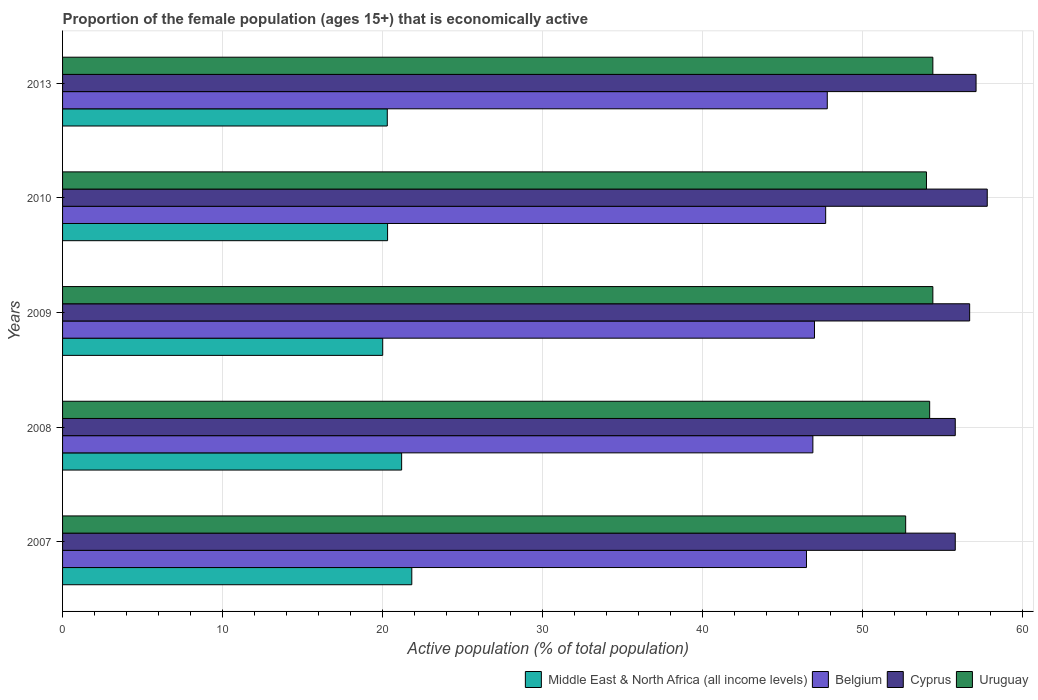Are the number of bars on each tick of the Y-axis equal?
Offer a very short reply. Yes. How many bars are there on the 5th tick from the bottom?
Your response must be concise. 4. What is the proportion of the female population that is economically active in Cyprus in 2007?
Give a very brief answer. 55.8. Across all years, what is the maximum proportion of the female population that is economically active in Uruguay?
Ensure brevity in your answer.  54.4. Across all years, what is the minimum proportion of the female population that is economically active in Cyprus?
Your response must be concise. 55.8. What is the total proportion of the female population that is economically active in Uruguay in the graph?
Your answer should be very brief. 269.7. What is the difference between the proportion of the female population that is economically active in Belgium in 2008 and that in 2009?
Provide a succinct answer. -0.1. What is the difference between the proportion of the female population that is economically active in Uruguay in 2009 and the proportion of the female population that is economically active in Cyprus in 2013?
Ensure brevity in your answer.  -2.7. What is the average proportion of the female population that is economically active in Cyprus per year?
Your response must be concise. 56.64. In the year 2013, what is the difference between the proportion of the female population that is economically active in Uruguay and proportion of the female population that is economically active in Cyprus?
Offer a very short reply. -2.7. In how many years, is the proportion of the female population that is economically active in Uruguay greater than 32 %?
Offer a very short reply. 5. What is the ratio of the proportion of the female population that is economically active in Belgium in 2007 to that in 2008?
Provide a short and direct response. 0.99. What is the difference between the highest and the second highest proportion of the female population that is economically active in Cyprus?
Your response must be concise. 0.7. What is the difference between the highest and the lowest proportion of the female population that is economically active in Middle East & North Africa (all income levels)?
Keep it short and to the point. 1.82. Is it the case that in every year, the sum of the proportion of the female population that is economically active in Middle East & North Africa (all income levels) and proportion of the female population that is economically active in Belgium is greater than the sum of proportion of the female population that is economically active in Uruguay and proportion of the female population that is economically active in Cyprus?
Your response must be concise. No. What does the 1st bar from the top in 2007 represents?
Your answer should be compact. Uruguay. What does the 4th bar from the bottom in 2010 represents?
Give a very brief answer. Uruguay. Is it the case that in every year, the sum of the proportion of the female population that is economically active in Middle East & North Africa (all income levels) and proportion of the female population that is economically active in Uruguay is greater than the proportion of the female population that is economically active in Belgium?
Keep it short and to the point. Yes. How many bars are there?
Provide a short and direct response. 20. How many years are there in the graph?
Offer a very short reply. 5. Are the values on the major ticks of X-axis written in scientific E-notation?
Ensure brevity in your answer.  No. How are the legend labels stacked?
Provide a short and direct response. Horizontal. What is the title of the graph?
Make the answer very short. Proportion of the female population (ages 15+) that is economically active. What is the label or title of the X-axis?
Your answer should be very brief. Active population (% of total population). What is the label or title of the Y-axis?
Provide a short and direct response. Years. What is the Active population (% of total population) of Middle East & North Africa (all income levels) in 2007?
Provide a succinct answer. 21.83. What is the Active population (% of total population) in Belgium in 2007?
Your response must be concise. 46.5. What is the Active population (% of total population) of Cyprus in 2007?
Keep it short and to the point. 55.8. What is the Active population (% of total population) in Uruguay in 2007?
Give a very brief answer. 52.7. What is the Active population (% of total population) of Middle East & North Africa (all income levels) in 2008?
Offer a very short reply. 21.19. What is the Active population (% of total population) in Belgium in 2008?
Offer a very short reply. 46.9. What is the Active population (% of total population) in Cyprus in 2008?
Provide a succinct answer. 55.8. What is the Active population (% of total population) in Uruguay in 2008?
Your answer should be compact. 54.2. What is the Active population (% of total population) of Middle East & North Africa (all income levels) in 2009?
Offer a terse response. 20.01. What is the Active population (% of total population) in Cyprus in 2009?
Give a very brief answer. 56.7. What is the Active population (% of total population) of Uruguay in 2009?
Give a very brief answer. 54.4. What is the Active population (% of total population) of Middle East & North Africa (all income levels) in 2010?
Your answer should be very brief. 20.32. What is the Active population (% of total population) in Belgium in 2010?
Offer a very short reply. 47.7. What is the Active population (% of total population) of Cyprus in 2010?
Offer a very short reply. 57.8. What is the Active population (% of total population) of Uruguay in 2010?
Your answer should be very brief. 54. What is the Active population (% of total population) of Middle East & North Africa (all income levels) in 2013?
Give a very brief answer. 20.3. What is the Active population (% of total population) in Belgium in 2013?
Offer a terse response. 47.8. What is the Active population (% of total population) in Cyprus in 2013?
Your response must be concise. 57.1. What is the Active population (% of total population) in Uruguay in 2013?
Your answer should be very brief. 54.4. Across all years, what is the maximum Active population (% of total population) of Middle East & North Africa (all income levels)?
Keep it short and to the point. 21.83. Across all years, what is the maximum Active population (% of total population) in Belgium?
Keep it short and to the point. 47.8. Across all years, what is the maximum Active population (% of total population) of Cyprus?
Provide a succinct answer. 57.8. Across all years, what is the maximum Active population (% of total population) in Uruguay?
Offer a terse response. 54.4. Across all years, what is the minimum Active population (% of total population) of Middle East & North Africa (all income levels)?
Ensure brevity in your answer.  20.01. Across all years, what is the minimum Active population (% of total population) of Belgium?
Your answer should be compact. 46.5. Across all years, what is the minimum Active population (% of total population) in Cyprus?
Your answer should be compact. 55.8. Across all years, what is the minimum Active population (% of total population) in Uruguay?
Offer a very short reply. 52.7. What is the total Active population (% of total population) of Middle East & North Africa (all income levels) in the graph?
Offer a terse response. 103.65. What is the total Active population (% of total population) in Belgium in the graph?
Provide a short and direct response. 235.9. What is the total Active population (% of total population) of Cyprus in the graph?
Your response must be concise. 283.2. What is the total Active population (% of total population) in Uruguay in the graph?
Make the answer very short. 269.7. What is the difference between the Active population (% of total population) of Middle East & North Africa (all income levels) in 2007 and that in 2008?
Give a very brief answer. 0.63. What is the difference between the Active population (% of total population) of Belgium in 2007 and that in 2008?
Provide a succinct answer. -0.4. What is the difference between the Active population (% of total population) of Uruguay in 2007 and that in 2008?
Provide a short and direct response. -1.5. What is the difference between the Active population (% of total population) of Middle East & North Africa (all income levels) in 2007 and that in 2009?
Provide a short and direct response. 1.82. What is the difference between the Active population (% of total population) in Cyprus in 2007 and that in 2009?
Your answer should be compact. -0.9. What is the difference between the Active population (% of total population) in Uruguay in 2007 and that in 2009?
Offer a terse response. -1.7. What is the difference between the Active population (% of total population) in Middle East & North Africa (all income levels) in 2007 and that in 2010?
Give a very brief answer. 1.51. What is the difference between the Active population (% of total population) of Cyprus in 2007 and that in 2010?
Ensure brevity in your answer.  -2. What is the difference between the Active population (% of total population) in Middle East & North Africa (all income levels) in 2007 and that in 2013?
Provide a succinct answer. 1.53. What is the difference between the Active population (% of total population) of Belgium in 2007 and that in 2013?
Your answer should be very brief. -1.3. What is the difference between the Active population (% of total population) of Cyprus in 2007 and that in 2013?
Your answer should be compact. -1.3. What is the difference between the Active population (% of total population) of Uruguay in 2007 and that in 2013?
Provide a succinct answer. -1.7. What is the difference between the Active population (% of total population) in Middle East & North Africa (all income levels) in 2008 and that in 2009?
Your answer should be compact. 1.18. What is the difference between the Active population (% of total population) of Belgium in 2008 and that in 2009?
Offer a terse response. -0.1. What is the difference between the Active population (% of total population) of Uruguay in 2008 and that in 2009?
Your response must be concise. -0.2. What is the difference between the Active population (% of total population) of Middle East & North Africa (all income levels) in 2008 and that in 2010?
Keep it short and to the point. 0.88. What is the difference between the Active population (% of total population) in Belgium in 2008 and that in 2010?
Provide a short and direct response. -0.8. What is the difference between the Active population (% of total population) in Middle East & North Africa (all income levels) in 2008 and that in 2013?
Ensure brevity in your answer.  0.9. What is the difference between the Active population (% of total population) of Belgium in 2008 and that in 2013?
Make the answer very short. -0.9. What is the difference between the Active population (% of total population) in Cyprus in 2008 and that in 2013?
Provide a succinct answer. -1.3. What is the difference between the Active population (% of total population) of Middle East & North Africa (all income levels) in 2009 and that in 2010?
Your response must be concise. -0.3. What is the difference between the Active population (% of total population) of Cyprus in 2009 and that in 2010?
Keep it short and to the point. -1.1. What is the difference between the Active population (% of total population) in Middle East & North Africa (all income levels) in 2009 and that in 2013?
Your answer should be compact. -0.29. What is the difference between the Active population (% of total population) of Belgium in 2009 and that in 2013?
Offer a terse response. -0.8. What is the difference between the Active population (% of total population) in Uruguay in 2009 and that in 2013?
Make the answer very short. 0. What is the difference between the Active population (% of total population) in Middle East & North Africa (all income levels) in 2010 and that in 2013?
Ensure brevity in your answer.  0.02. What is the difference between the Active population (% of total population) in Middle East & North Africa (all income levels) in 2007 and the Active population (% of total population) in Belgium in 2008?
Offer a very short reply. -25.07. What is the difference between the Active population (% of total population) of Middle East & North Africa (all income levels) in 2007 and the Active population (% of total population) of Cyprus in 2008?
Offer a very short reply. -33.97. What is the difference between the Active population (% of total population) in Middle East & North Africa (all income levels) in 2007 and the Active population (% of total population) in Uruguay in 2008?
Your response must be concise. -32.37. What is the difference between the Active population (% of total population) of Middle East & North Africa (all income levels) in 2007 and the Active population (% of total population) of Belgium in 2009?
Make the answer very short. -25.17. What is the difference between the Active population (% of total population) of Middle East & North Africa (all income levels) in 2007 and the Active population (% of total population) of Cyprus in 2009?
Your answer should be very brief. -34.87. What is the difference between the Active population (% of total population) in Middle East & North Africa (all income levels) in 2007 and the Active population (% of total population) in Uruguay in 2009?
Keep it short and to the point. -32.57. What is the difference between the Active population (% of total population) of Belgium in 2007 and the Active population (% of total population) of Cyprus in 2009?
Your answer should be very brief. -10.2. What is the difference between the Active population (% of total population) of Middle East & North Africa (all income levels) in 2007 and the Active population (% of total population) of Belgium in 2010?
Provide a short and direct response. -25.87. What is the difference between the Active population (% of total population) of Middle East & North Africa (all income levels) in 2007 and the Active population (% of total population) of Cyprus in 2010?
Keep it short and to the point. -35.97. What is the difference between the Active population (% of total population) of Middle East & North Africa (all income levels) in 2007 and the Active population (% of total population) of Uruguay in 2010?
Keep it short and to the point. -32.17. What is the difference between the Active population (% of total population) in Belgium in 2007 and the Active population (% of total population) in Cyprus in 2010?
Provide a succinct answer. -11.3. What is the difference between the Active population (% of total population) of Belgium in 2007 and the Active population (% of total population) of Uruguay in 2010?
Keep it short and to the point. -7.5. What is the difference between the Active population (% of total population) of Middle East & North Africa (all income levels) in 2007 and the Active population (% of total population) of Belgium in 2013?
Give a very brief answer. -25.97. What is the difference between the Active population (% of total population) in Middle East & North Africa (all income levels) in 2007 and the Active population (% of total population) in Cyprus in 2013?
Keep it short and to the point. -35.27. What is the difference between the Active population (% of total population) of Middle East & North Africa (all income levels) in 2007 and the Active population (% of total population) of Uruguay in 2013?
Ensure brevity in your answer.  -32.57. What is the difference between the Active population (% of total population) in Belgium in 2007 and the Active population (% of total population) in Cyprus in 2013?
Offer a terse response. -10.6. What is the difference between the Active population (% of total population) of Middle East & North Africa (all income levels) in 2008 and the Active population (% of total population) of Belgium in 2009?
Offer a terse response. -25.81. What is the difference between the Active population (% of total population) of Middle East & North Africa (all income levels) in 2008 and the Active population (% of total population) of Cyprus in 2009?
Ensure brevity in your answer.  -35.51. What is the difference between the Active population (% of total population) in Middle East & North Africa (all income levels) in 2008 and the Active population (% of total population) in Uruguay in 2009?
Give a very brief answer. -33.21. What is the difference between the Active population (% of total population) of Middle East & North Africa (all income levels) in 2008 and the Active population (% of total population) of Belgium in 2010?
Keep it short and to the point. -26.51. What is the difference between the Active population (% of total population) of Middle East & North Africa (all income levels) in 2008 and the Active population (% of total population) of Cyprus in 2010?
Provide a succinct answer. -36.61. What is the difference between the Active population (% of total population) in Middle East & North Africa (all income levels) in 2008 and the Active population (% of total population) in Uruguay in 2010?
Your answer should be very brief. -32.81. What is the difference between the Active population (% of total population) in Cyprus in 2008 and the Active population (% of total population) in Uruguay in 2010?
Keep it short and to the point. 1.8. What is the difference between the Active population (% of total population) in Middle East & North Africa (all income levels) in 2008 and the Active population (% of total population) in Belgium in 2013?
Your answer should be very brief. -26.61. What is the difference between the Active population (% of total population) in Middle East & North Africa (all income levels) in 2008 and the Active population (% of total population) in Cyprus in 2013?
Provide a short and direct response. -35.91. What is the difference between the Active population (% of total population) in Middle East & North Africa (all income levels) in 2008 and the Active population (% of total population) in Uruguay in 2013?
Offer a very short reply. -33.21. What is the difference between the Active population (% of total population) in Belgium in 2008 and the Active population (% of total population) in Cyprus in 2013?
Keep it short and to the point. -10.2. What is the difference between the Active population (% of total population) in Cyprus in 2008 and the Active population (% of total population) in Uruguay in 2013?
Provide a succinct answer. 1.4. What is the difference between the Active population (% of total population) in Middle East & North Africa (all income levels) in 2009 and the Active population (% of total population) in Belgium in 2010?
Ensure brevity in your answer.  -27.69. What is the difference between the Active population (% of total population) in Middle East & North Africa (all income levels) in 2009 and the Active population (% of total population) in Cyprus in 2010?
Provide a short and direct response. -37.79. What is the difference between the Active population (% of total population) in Middle East & North Africa (all income levels) in 2009 and the Active population (% of total population) in Uruguay in 2010?
Make the answer very short. -33.99. What is the difference between the Active population (% of total population) in Middle East & North Africa (all income levels) in 2009 and the Active population (% of total population) in Belgium in 2013?
Your response must be concise. -27.79. What is the difference between the Active population (% of total population) in Middle East & North Africa (all income levels) in 2009 and the Active population (% of total population) in Cyprus in 2013?
Provide a short and direct response. -37.09. What is the difference between the Active population (% of total population) of Middle East & North Africa (all income levels) in 2009 and the Active population (% of total population) of Uruguay in 2013?
Your answer should be compact. -34.39. What is the difference between the Active population (% of total population) in Belgium in 2009 and the Active population (% of total population) in Cyprus in 2013?
Provide a short and direct response. -10.1. What is the difference between the Active population (% of total population) in Belgium in 2009 and the Active population (% of total population) in Uruguay in 2013?
Ensure brevity in your answer.  -7.4. What is the difference between the Active population (% of total population) of Middle East & North Africa (all income levels) in 2010 and the Active population (% of total population) of Belgium in 2013?
Offer a very short reply. -27.48. What is the difference between the Active population (% of total population) in Middle East & North Africa (all income levels) in 2010 and the Active population (% of total population) in Cyprus in 2013?
Give a very brief answer. -36.78. What is the difference between the Active population (% of total population) of Middle East & North Africa (all income levels) in 2010 and the Active population (% of total population) of Uruguay in 2013?
Your answer should be compact. -34.08. What is the difference between the Active population (% of total population) of Belgium in 2010 and the Active population (% of total population) of Cyprus in 2013?
Your answer should be very brief. -9.4. What is the difference between the Active population (% of total population) in Cyprus in 2010 and the Active population (% of total population) in Uruguay in 2013?
Offer a very short reply. 3.4. What is the average Active population (% of total population) in Middle East & North Africa (all income levels) per year?
Offer a terse response. 20.73. What is the average Active population (% of total population) of Belgium per year?
Provide a succinct answer. 47.18. What is the average Active population (% of total population) of Cyprus per year?
Your answer should be compact. 56.64. What is the average Active population (% of total population) in Uruguay per year?
Your answer should be very brief. 53.94. In the year 2007, what is the difference between the Active population (% of total population) of Middle East & North Africa (all income levels) and Active population (% of total population) of Belgium?
Offer a terse response. -24.67. In the year 2007, what is the difference between the Active population (% of total population) in Middle East & North Africa (all income levels) and Active population (% of total population) in Cyprus?
Your answer should be compact. -33.97. In the year 2007, what is the difference between the Active population (% of total population) of Middle East & North Africa (all income levels) and Active population (% of total population) of Uruguay?
Offer a very short reply. -30.87. In the year 2007, what is the difference between the Active population (% of total population) of Belgium and Active population (% of total population) of Cyprus?
Provide a succinct answer. -9.3. In the year 2007, what is the difference between the Active population (% of total population) in Cyprus and Active population (% of total population) in Uruguay?
Offer a terse response. 3.1. In the year 2008, what is the difference between the Active population (% of total population) of Middle East & North Africa (all income levels) and Active population (% of total population) of Belgium?
Offer a terse response. -25.71. In the year 2008, what is the difference between the Active population (% of total population) of Middle East & North Africa (all income levels) and Active population (% of total population) of Cyprus?
Your response must be concise. -34.61. In the year 2008, what is the difference between the Active population (% of total population) in Middle East & North Africa (all income levels) and Active population (% of total population) in Uruguay?
Keep it short and to the point. -33.01. In the year 2008, what is the difference between the Active population (% of total population) of Belgium and Active population (% of total population) of Cyprus?
Make the answer very short. -8.9. In the year 2009, what is the difference between the Active population (% of total population) of Middle East & North Africa (all income levels) and Active population (% of total population) of Belgium?
Provide a succinct answer. -26.99. In the year 2009, what is the difference between the Active population (% of total population) of Middle East & North Africa (all income levels) and Active population (% of total population) of Cyprus?
Offer a terse response. -36.69. In the year 2009, what is the difference between the Active population (% of total population) of Middle East & North Africa (all income levels) and Active population (% of total population) of Uruguay?
Provide a short and direct response. -34.39. In the year 2009, what is the difference between the Active population (% of total population) in Belgium and Active population (% of total population) in Cyprus?
Your answer should be very brief. -9.7. In the year 2009, what is the difference between the Active population (% of total population) of Belgium and Active population (% of total population) of Uruguay?
Make the answer very short. -7.4. In the year 2010, what is the difference between the Active population (% of total population) in Middle East & North Africa (all income levels) and Active population (% of total population) in Belgium?
Keep it short and to the point. -27.38. In the year 2010, what is the difference between the Active population (% of total population) of Middle East & North Africa (all income levels) and Active population (% of total population) of Cyprus?
Provide a succinct answer. -37.48. In the year 2010, what is the difference between the Active population (% of total population) of Middle East & North Africa (all income levels) and Active population (% of total population) of Uruguay?
Offer a terse response. -33.68. In the year 2010, what is the difference between the Active population (% of total population) in Belgium and Active population (% of total population) in Cyprus?
Ensure brevity in your answer.  -10.1. In the year 2013, what is the difference between the Active population (% of total population) in Middle East & North Africa (all income levels) and Active population (% of total population) in Belgium?
Ensure brevity in your answer.  -27.5. In the year 2013, what is the difference between the Active population (% of total population) of Middle East & North Africa (all income levels) and Active population (% of total population) of Cyprus?
Make the answer very short. -36.8. In the year 2013, what is the difference between the Active population (% of total population) of Middle East & North Africa (all income levels) and Active population (% of total population) of Uruguay?
Provide a short and direct response. -34.1. In the year 2013, what is the difference between the Active population (% of total population) of Cyprus and Active population (% of total population) of Uruguay?
Provide a short and direct response. 2.7. What is the ratio of the Active population (% of total population) of Middle East & North Africa (all income levels) in 2007 to that in 2008?
Ensure brevity in your answer.  1.03. What is the ratio of the Active population (% of total population) in Cyprus in 2007 to that in 2008?
Provide a succinct answer. 1. What is the ratio of the Active population (% of total population) of Uruguay in 2007 to that in 2008?
Give a very brief answer. 0.97. What is the ratio of the Active population (% of total population) in Middle East & North Africa (all income levels) in 2007 to that in 2009?
Provide a succinct answer. 1.09. What is the ratio of the Active population (% of total population) of Cyprus in 2007 to that in 2009?
Your answer should be compact. 0.98. What is the ratio of the Active population (% of total population) in Uruguay in 2007 to that in 2009?
Keep it short and to the point. 0.97. What is the ratio of the Active population (% of total population) of Middle East & North Africa (all income levels) in 2007 to that in 2010?
Provide a short and direct response. 1.07. What is the ratio of the Active population (% of total population) in Belgium in 2007 to that in 2010?
Make the answer very short. 0.97. What is the ratio of the Active population (% of total population) of Cyprus in 2007 to that in 2010?
Your answer should be very brief. 0.97. What is the ratio of the Active population (% of total population) of Uruguay in 2007 to that in 2010?
Ensure brevity in your answer.  0.98. What is the ratio of the Active population (% of total population) of Middle East & North Africa (all income levels) in 2007 to that in 2013?
Provide a short and direct response. 1.08. What is the ratio of the Active population (% of total population) in Belgium in 2007 to that in 2013?
Make the answer very short. 0.97. What is the ratio of the Active population (% of total population) of Cyprus in 2007 to that in 2013?
Your response must be concise. 0.98. What is the ratio of the Active population (% of total population) of Uruguay in 2007 to that in 2013?
Give a very brief answer. 0.97. What is the ratio of the Active population (% of total population) of Middle East & North Africa (all income levels) in 2008 to that in 2009?
Keep it short and to the point. 1.06. What is the ratio of the Active population (% of total population) in Cyprus in 2008 to that in 2009?
Keep it short and to the point. 0.98. What is the ratio of the Active population (% of total population) in Uruguay in 2008 to that in 2009?
Make the answer very short. 1. What is the ratio of the Active population (% of total population) of Middle East & North Africa (all income levels) in 2008 to that in 2010?
Your answer should be very brief. 1.04. What is the ratio of the Active population (% of total population) of Belgium in 2008 to that in 2010?
Make the answer very short. 0.98. What is the ratio of the Active population (% of total population) of Cyprus in 2008 to that in 2010?
Your answer should be compact. 0.97. What is the ratio of the Active population (% of total population) of Middle East & North Africa (all income levels) in 2008 to that in 2013?
Make the answer very short. 1.04. What is the ratio of the Active population (% of total population) of Belgium in 2008 to that in 2013?
Provide a succinct answer. 0.98. What is the ratio of the Active population (% of total population) in Cyprus in 2008 to that in 2013?
Provide a short and direct response. 0.98. What is the ratio of the Active population (% of total population) of Uruguay in 2008 to that in 2013?
Make the answer very short. 1. What is the ratio of the Active population (% of total population) in Cyprus in 2009 to that in 2010?
Your answer should be compact. 0.98. What is the ratio of the Active population (% of total population) in Uruguay in 2009 to that in 2010?
Provide a succinct answer. 1.01. What is the ratio of the Active population (% of total population) of Middle East & North Africa (all income levels) in 2009 to that in 2013?
Keep it short and to the point. 0.99. What is the ratio of the Active population (% of total population) of Belgium in 2009 to that in 2013?
Provide a succinct answer. 0.98. What is the ratio of the Active population (% of total population) of Cyprus in 2009 to that in 2013?
Your answer should be very brief. 0.99. What is the ratio of the Active population (% of total population) of Cyprus in 2010 to that in 2013?
Make the answer very short. 1.01. What is the ratio of the Active population (% of total population) of Uruguay in 2010 to that in 2013?
Your answer should be very brief. 0.99. What is the difference between the highest and the second highest Active population (% of total population) in Middle East & North Africa (all income levels)?
Give a very brief answer. 0.63. What is the difference between the highest and the second highest Active population (% of total population) of Belgium?
Your answer should be very brief. 0.1. What is the difference between the highest and the second highest Active population (% of total population) of Cyprus?
Give a very brief answer. 0.7. What is the difference between the highest and the second highest Active population (% of total population) of Uruguay?
Your answer should be compact. 0. What is the difference between the highest and the lowest Active population (% of total population) in Middle East & North Africa (all income levels)?
Provide a short and direct response. 1.82. What is the difference between the highest and the lowest Active population (% of total population) in Belgium?
Your response must be concise. 1.3. What is the difference between the highest and the lowest Active population (% of total population) in Cyprus?
Your answer should be compact. 2. 